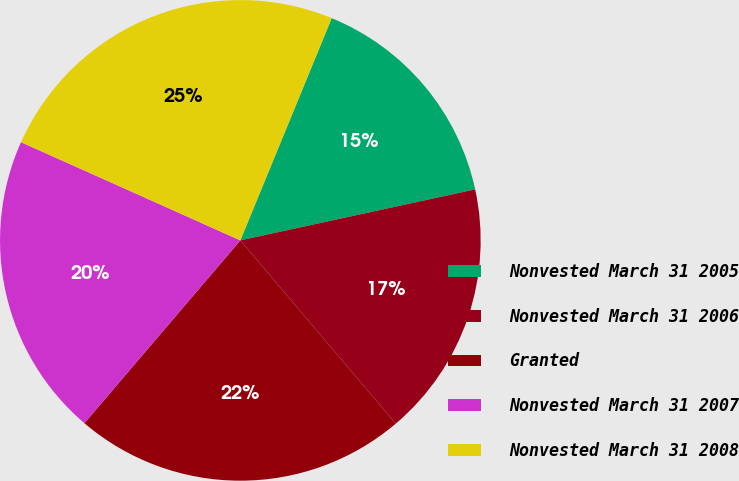Convert chart to OTSL. <chart><loc_0><loc_0><loc_500><loc_500><pie_chart><fcel>Nonvested March 31 2005<fcel>Nonvested March 31 2006<fcel>Granted<fcel>Nonvested March 31 2007<fcel>Nonvested March 31 2008<nl><fcel>15.39%<fcel>17.21%<fcel>22.44%<fcel>20.46%<fcel>24.51%<nl></chart> 